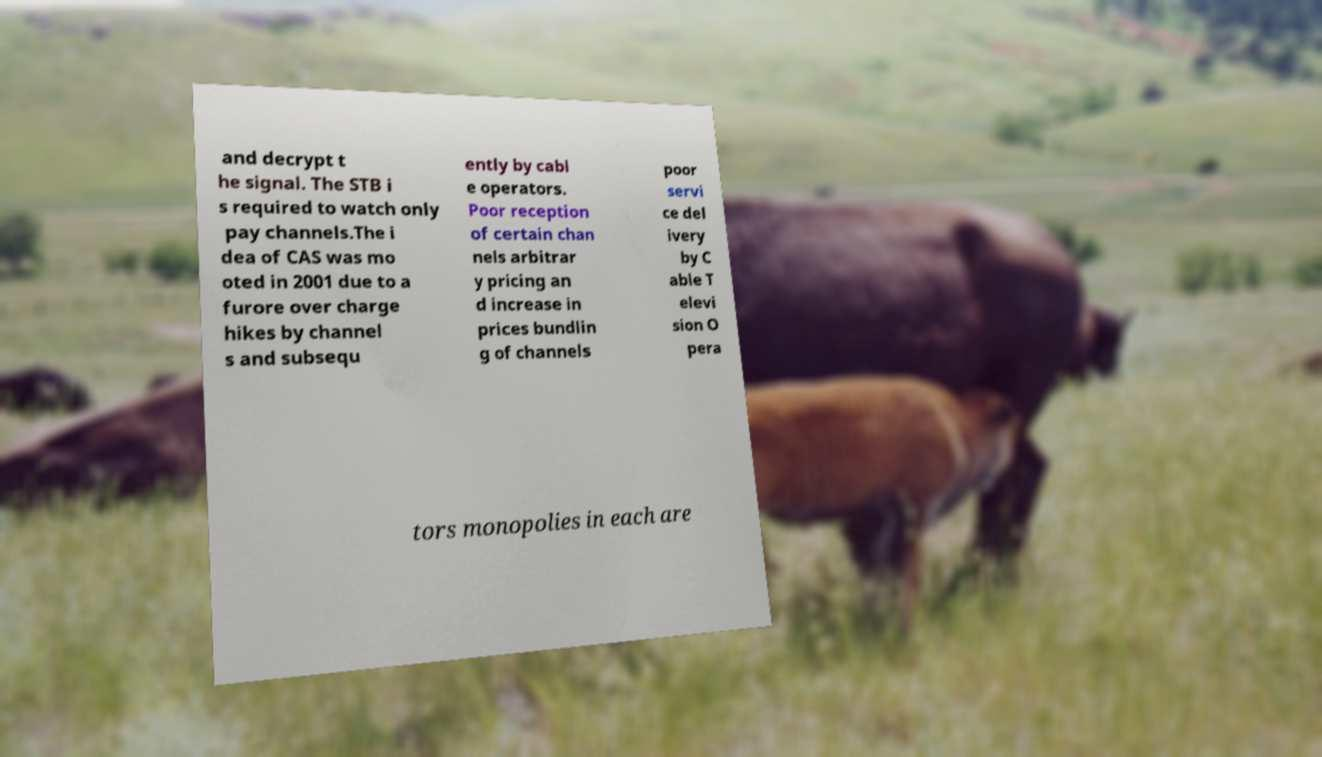Can you read and provide the text displayed in the image?This photo seems to have some interesting text. Can you extract and type it out for me? and decrypt t he signal. The STB i s required to watch only pay channels.The i dea of CAS was mo oted in 2001 due to a furore over charge hikes by channel s and subsequ ently by cabl e operators. Poor reception of certain chan nels arbitrar y pricing an d increase in prices bundlin g of channels poor servi ce del ivery by C able T elevi sion O pera tors monopolies in each are 